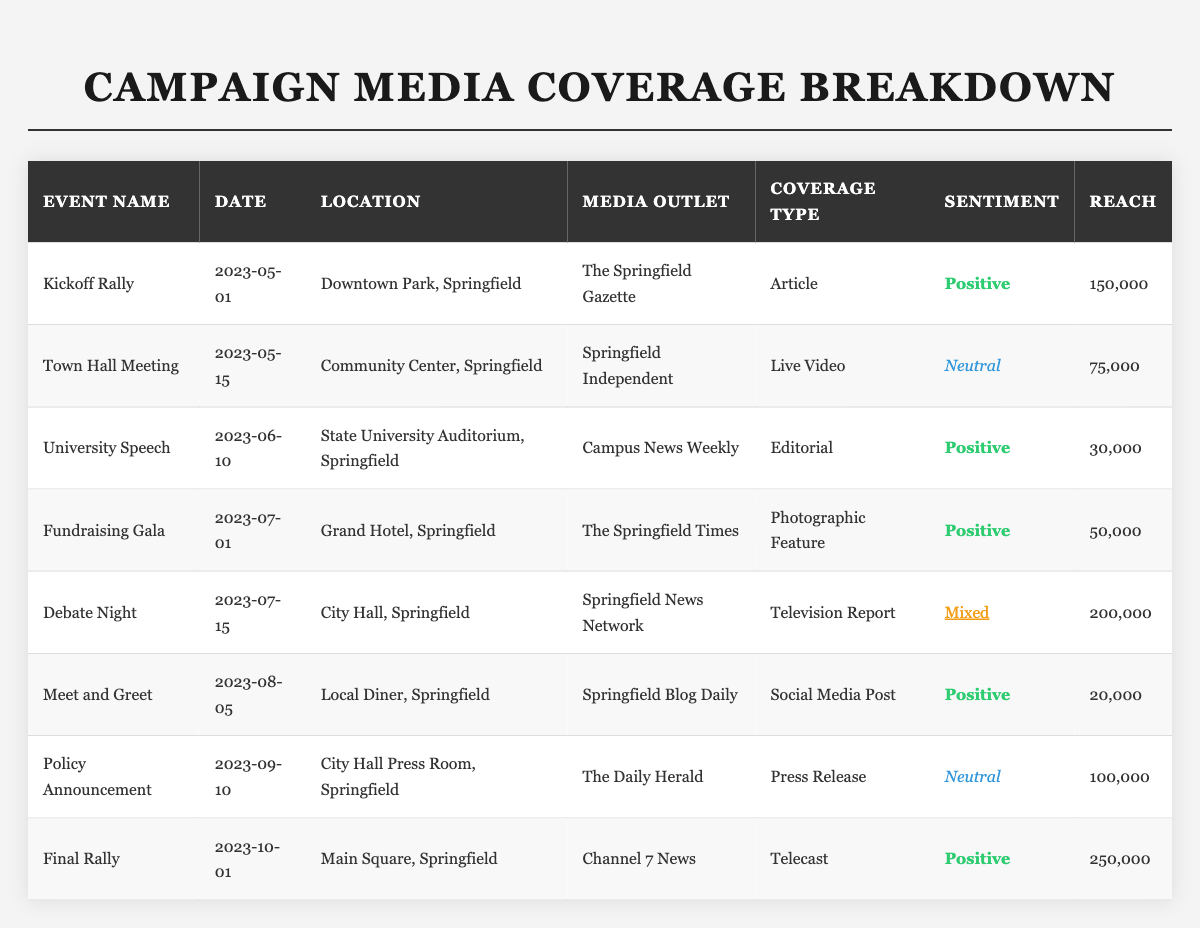What media outlet covered the Kickoff Rally? The table lists "The Springfield Gazette" as the media outlet for the Kickoff Rally.
Answer: The Springfield Gazette Which event had the highest reach? The Final Rally had a reach of 250,000, which is higher than any other event listed in the table.
Answer: Final Rally How many events had a positive sentiment? The events with positive sentiment are the Kickoff Rally, University Speech, Fundraising Gala, Meet and Greet, and Final Rally, totaling five events.
Answer: 5 What is the coverage type for the Debate Night event? The coverage type for Debate Night is identified in the table as "Television Report."
Answer: Television Report Did the Town Hall Meeting receive a positive sentiment coverage? Based on the table, the Town Hall Meeting has a neutral sentiment, so it did not receive a positive sentiment coverage.
Answer: No Which coverage type had the least reach based on the table? The Social Media Post for the Meet and Greet event had the least reach of 20,000 compared to other events listed.
Answer: Social Media Post What is the average reach of all events listed? The total reach is (150,000 + 75,000 + 30,000 + 50,000 + 200,000 + 20,000 + 100,000 + 250,000) = 875,000. There are 8 events, thus the average reach is 875,000 / 8 = 109,375.
Answer: 109,375 For which event was the sentiment classified as mixed, and how many reached? The Debate Night event's sentiment is classified as mixed and it had a reach of 200,000.
Answer: Debate Night, 200,000 Which sentiment type had the highest reach collectively across the events? To find out, sum the reach for each sentiment: Positive (150,000 + 30,000 + 50,000 + 20,000 + 250,000 = 500,000), Neutral (75,000 + 100,000 = 175,000), Mixed (200,000). Thus, Positive has the highest collective reach.
Answer: Positive List the events with a reach greater than 100,000. The Kickoff Rally, Debate Night, and Final Rally had a reach greater than 100,000, with reach figures of 150,000, 200,000, and 250,000 respectively.
Answer: Kickoff Rally, Debate Night, Final Rally 